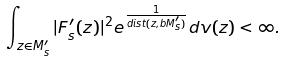<formula> <loc_0><loc_0><loc_500><loc_500>\int _ { z \in M _ { s } ^ { \prime } } | F _ { s } ^ { \prime } ( z ) | ^ { 2 } e ^ { \frac { 1 } { d i s t ( z , b M _ { s } ^ { \prime } ) } } d v ( z ) < \infty .</formula> 